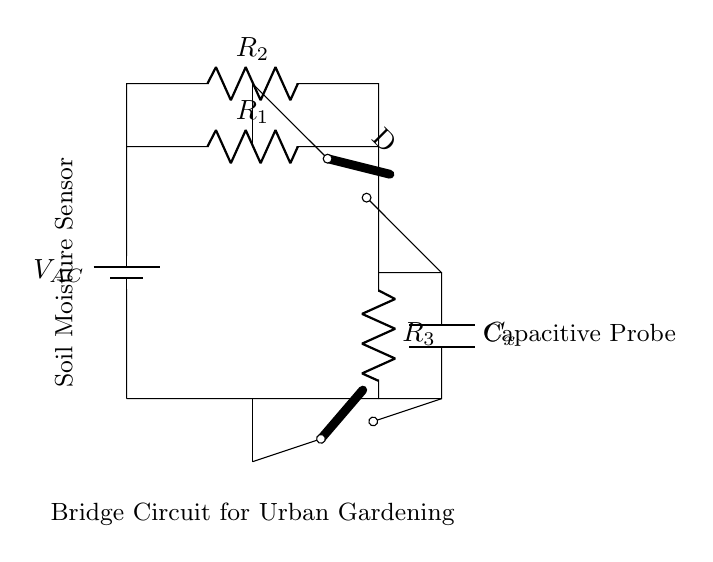What is the function of the battery in this circuit? The battery provides the alternating current voltage for the operation of the circuit. It is essential for powering the circuit and enabling the measurement of capacitance.
Answer: Voltage source What type of components are R1, R2, R3? R1, R2, and R3 are resistors. They are part of the bridge circuit that helps to balance the network and measure the capacitance change due to soil moisture.
Answer: Resistors How many capacitors are present in the circuit? There is one capacitor in the circuit, labeled as Cx. It is used in conjunction with the resistors to form a bridge that detects changes in soil moisture through capacitance variation.
Answer: One What does the switch labeled "D" allow in this circuit? The switch labeled "D" allows for the connection or disconnection of the capacitive probe in the circuit, enabling or stopping the measurement process based on the moisture levels in the soil.
Answer: Connection control What might a higher resistance value in R1 indicate in this circuit? A higher resistance value in R1 increases the time constant of the circuit, which could lead to slower response times to changes in moisture but potentially enhances sensitivity to smaller changes in capacitance.
Answer: Slower response What is the role of Cx in this bridge circuit? Cx serves as the capacitive sensor that detects soil moisture levels. Its capacitance changes based on the moisture content, influencing the balance of the bridge circuit and thus providing a measurement output.
Answer: Soil moisture detection 